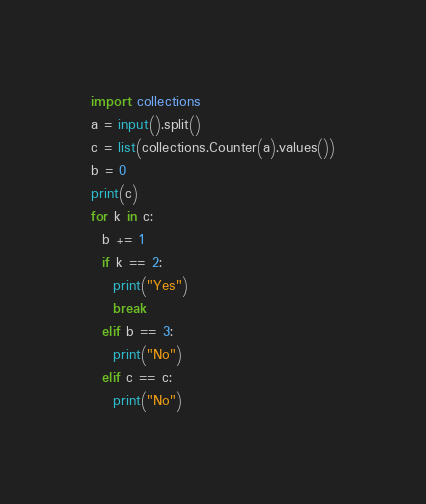Convert code to text. <code><loc_0><loc_0><loc_500><loc_500><_Python_>import collections
a = input().split()
c = list(collections.Counter(a).values())
b = 0
print(c)
for k in c:
  b += 1
  if k == 2:
    print("Yes")
    break
  elif b == 3:
    print("No")
  elif c == c:
    print("No")</code> 